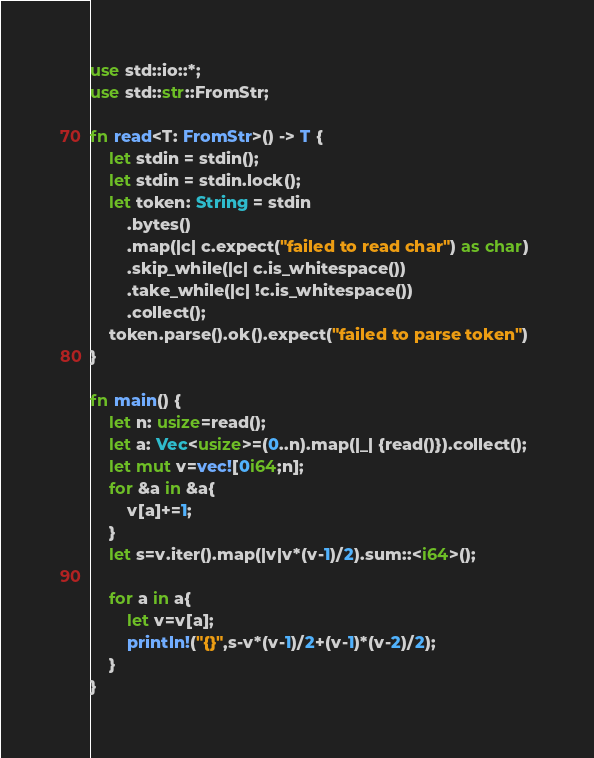Convert code to text. <code><loc_0><loc_0><loc_500><loc_500><_Rust_>use std::io::*;
use std::str::FromStr;

fn read<T: FromStr>() -> T {
    let stdin = stdin();
    let stdin = stdin.lock();
    let token: String = stdin
        .bytes()
        .map(|c| c.expect("failed to read char") as char) 
        .skip_while(|c| c.is_whitespace())
        .take_while(|c| !c.is_whitespace())
        .collect();
    token.parse().ok().expect("failed to parse token")
}

fn main() {
    let n: usize=read();
    let a: Vec<usize>=(0..n).map(|_| {read()}).collect();
    let mut v=vec![0i64;n];
    for &a in &a{
        v[a]+=1;
    }
    let s=v.iter().map(|v|v*(v-1)/2).sum::<i64>();

    for a in a{
        let v=v[a];
        println!("{}",s-v*(v-1)/2+(v-1)*(v-2)/2);
    }
}</code> 